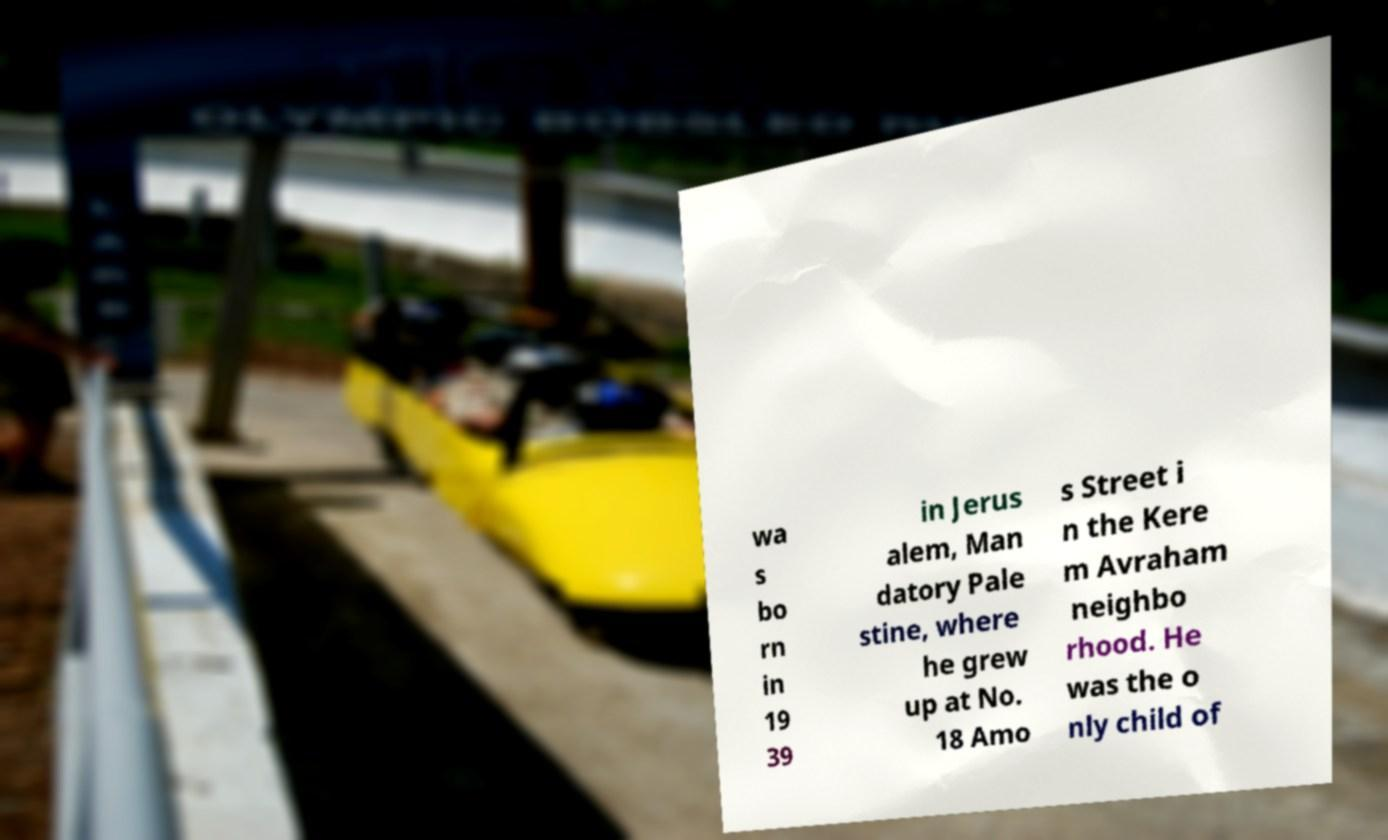Can you accurately transcribe the text from the provided image for me? wa s bo rn in 19 39 in Jerus alem, Man datory Pale stine, where he grew up at No. 18 Amo s Street i n the Kere m Avraham neighbo rhood. He was the o nly child of 